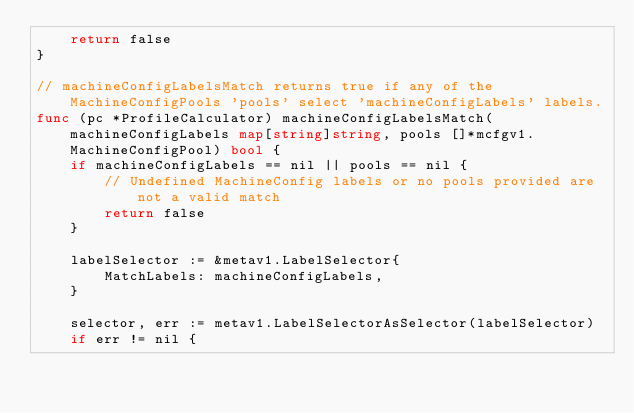Convert code to text. <code><loc_0><loc_0><loc_500><loc_500><_Go_>	return false
}

// machineConfigLabelsMatch returns true if any of the MachineConfigPools 'pools' select 'machineConfigLabels' labels.
func (pc *ProfileCalculator) machineConfigLabelsMatch(machineConfigLabels map[string]string, pools []*mcfgv1.MachineConfigPool) bool {
	if machineConfigLabels == nil || pools == nil {
		// Undefined MachineConfig labels or no pools provided are not a valid match
		return false
	}

	labelSelector := &metav1.LabelSelector{
		MatchLabels: machineConfigLabels,
	}

	selector, err := metav1.LabelSelectorAsSelector(labelSelector)
	if err != nil {</code> 